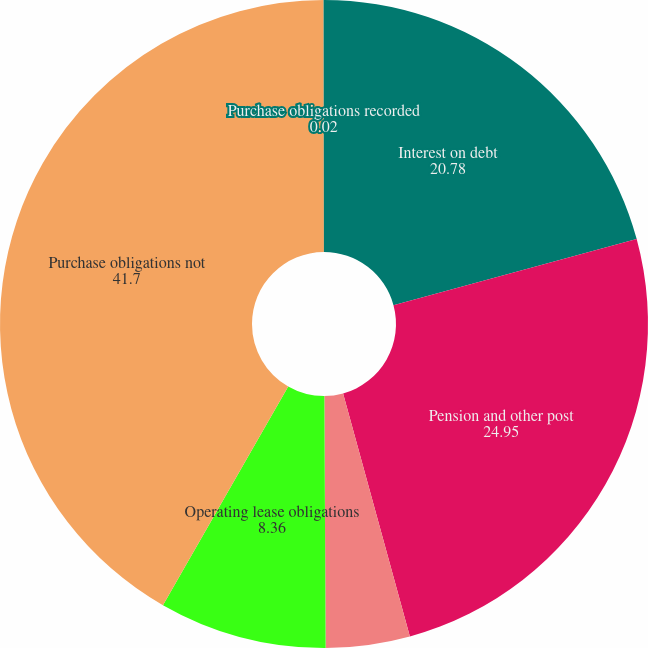<chart> <loc_0><loc_0><loc_500><loc_500><pie_chart><fcel>Interest on debt<fcel>Pension and other post<fcel>Capital lease obligations<fcel>Operating lease obligations<fcel>Purchase obligations not<fcel>Purchase obligations recorded<nl><fcel>20.78%<fcel>24.95%<fcel>4.19%<fcel>8.36%<fcel>41.7%<fcel>0.02%<nl></chart> 